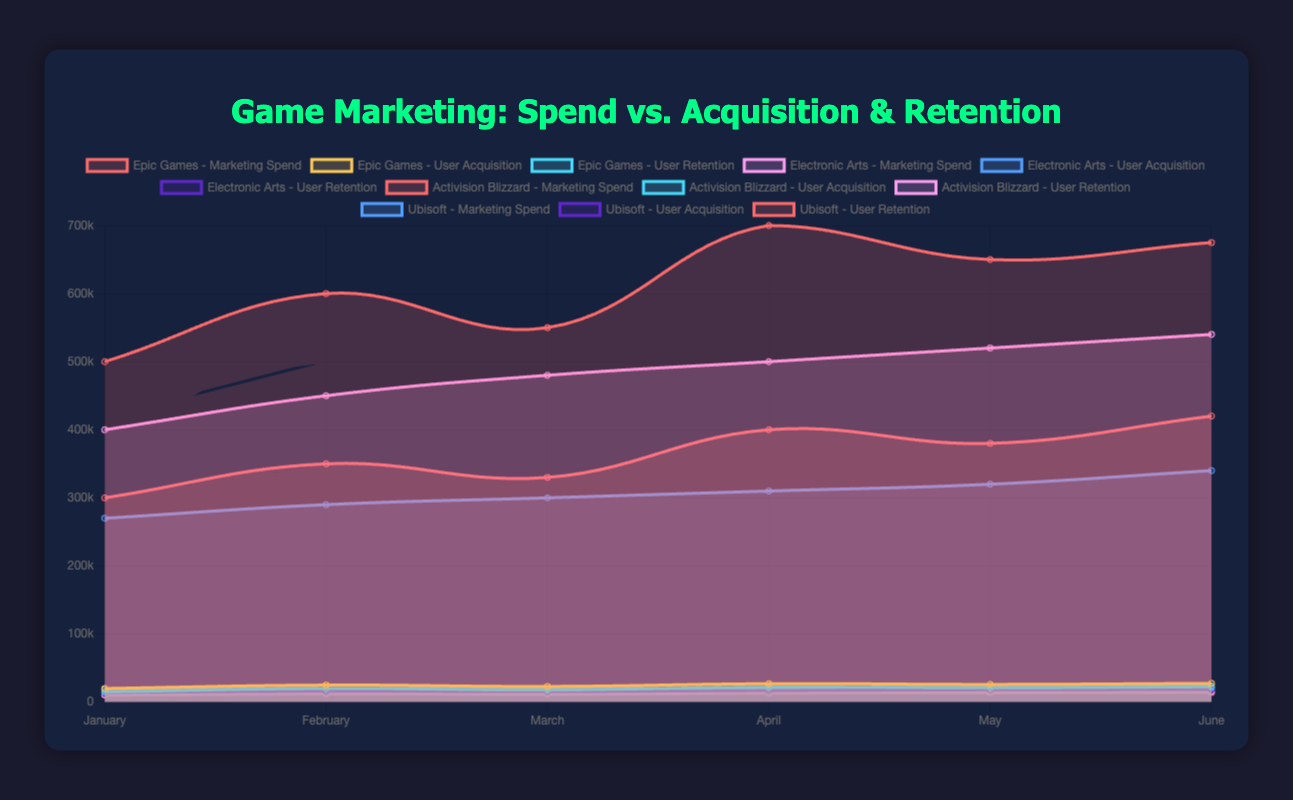What's the overall trend in marketing spend for Epic Games from January to June? The marketing spend for Epic Games shows an overall increasing trend from January ($500,000) to June ($675,000), with some fluctuations along the way.
Answer: Increasing Which company had the highest user acquisition in March? In March, Epic Games had the highest user acquisition with 23,000 users.
Answer: Epic Games What is the sum of user retention numbers for Ubisoft from January to June? Adding up all the retention numbers for Ubisoft from January to June: 10,000 + 12,000 + 11,500 + 13,000 + 13,500 + 14,000 = 74,000.
Answer: 74,000 How does the user acquisition for Electronic Arts in June compare to Epic Games in the same month? In June, the user acquisition for Electronic Arts was 23,500, compared to Epic Games' 27,500. Electronic Arts' user acquisition was lower.
Answer: Lower What was the average marketing spend for Activision Blizzard over the six months? Summing up the marketing spends for Activision Blizzard and dividing by six: (300,000 + 350,000 + 330,000 + 400,000 + 380,000 + 420,000) / 6 = 2,180,000 / 6 ≈ 363,333.33.
Answer: Approximately 363,333.33 Which company showed the least growth in user retention from January to June? Comparing the user retention from January to June for all companies, Ubisoft had the smallest increase, growing from 10,000 to 14,000, a difference of 4,000.
Answer: Ubisoft What is the ratio of user acquisition to marketing spend for Epic Games in January? For January, the user acquisition for Epic Games is 20,000 and the marketing spend is 500,000. The ratio is 20,000 / 500,000 = 0.04.
Answer: 0.04 Is there a month where all companies except one had decreasing user acquisition? If yes, which month and which company had an increase? Yes, in April, all companies except Epic Games saw a decrease in user acquisition. Epic Games' user acquisition increased from 23,000 to 27,000.
Answer: April, Epic Games 